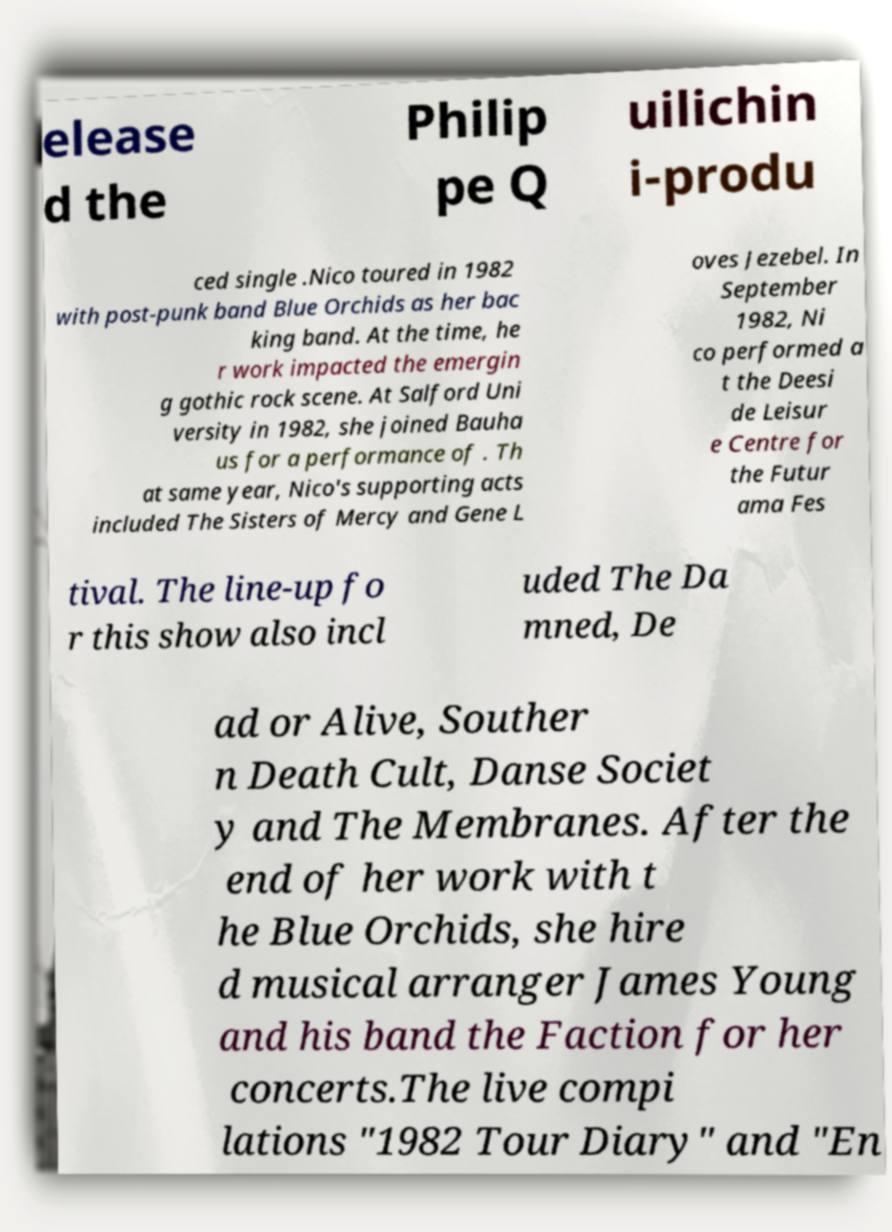Can you read and provide the text displayed in the image?This photo seems to have some interesting text. Can you extract and type it out for me? elease d the Philip pe Q uilichin i-produ ced single .Nico toured in 1982 with post-punk band Blue Orchids as her bac king band. At the time, he r work impacted the emergin g gothic rock scene. At Salford Uni versity in 1982, she joined Bauha us for a performance of . Th at same year, Nico's supporting acts included The Sisters of Mercy and Gene L oves Jezebel. In September 1982, Ni co performed a t the Deesi de Leisur e Centre for the Futur ama Fes tival. The line-up fo r this show also incl uded The Da mned, De ad or Alive, Souther n Death Cult, Danse Societ y and The Membranes. After the end of her work with t he Blue Orchids, she hire d musical arranger James Young and his band the Faction for her concerts.The live compi lations "1982 Tour Diary" and "En 